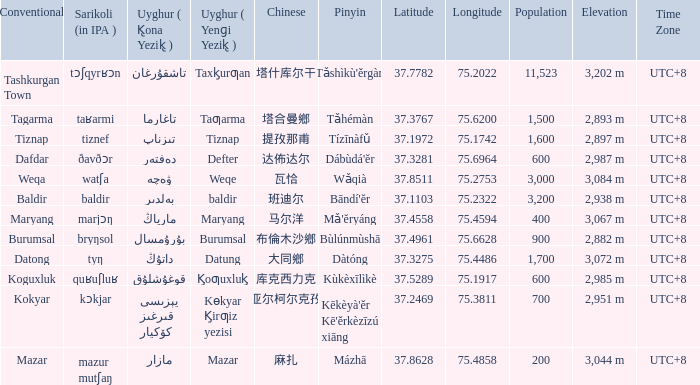Name the pinyin for  kɵkyar k̡irƣiz yezisi Kēkèyà'ěr Kē'ěrkèzīzú xiāng. 